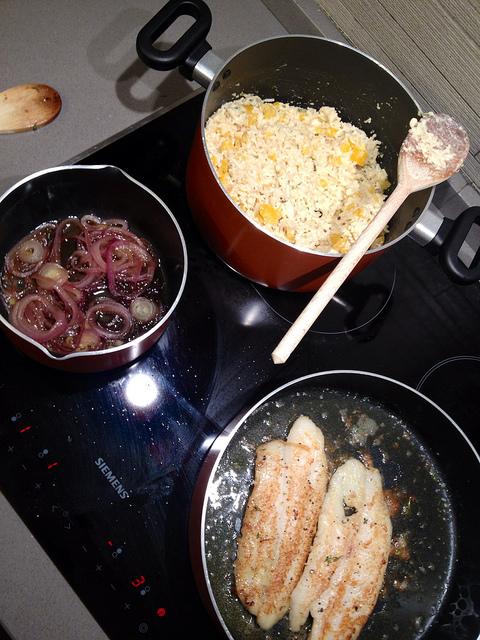How many pots are on the stove?
Short answer required. 3. How many wooden spoons do you see?
Concise answer only. 2. Who is making the food?
Write a very short answer. Cook. 